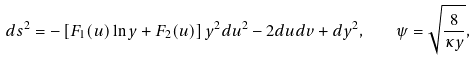<formula> <loc_0><loc_0><loc_500><loc_500>d s ^ { 2 } = - \left [ F _ { 1 } ( u ) \ln { y } + F _ { 2 } ( u ) \right ] y ^ { 2 } d u ^ { 2 } - 2 d u d v + d y ^ { 2 } , \quad \psi = \sqrt { \frac { 8 } { \kappa { y } } } ,</formula> 